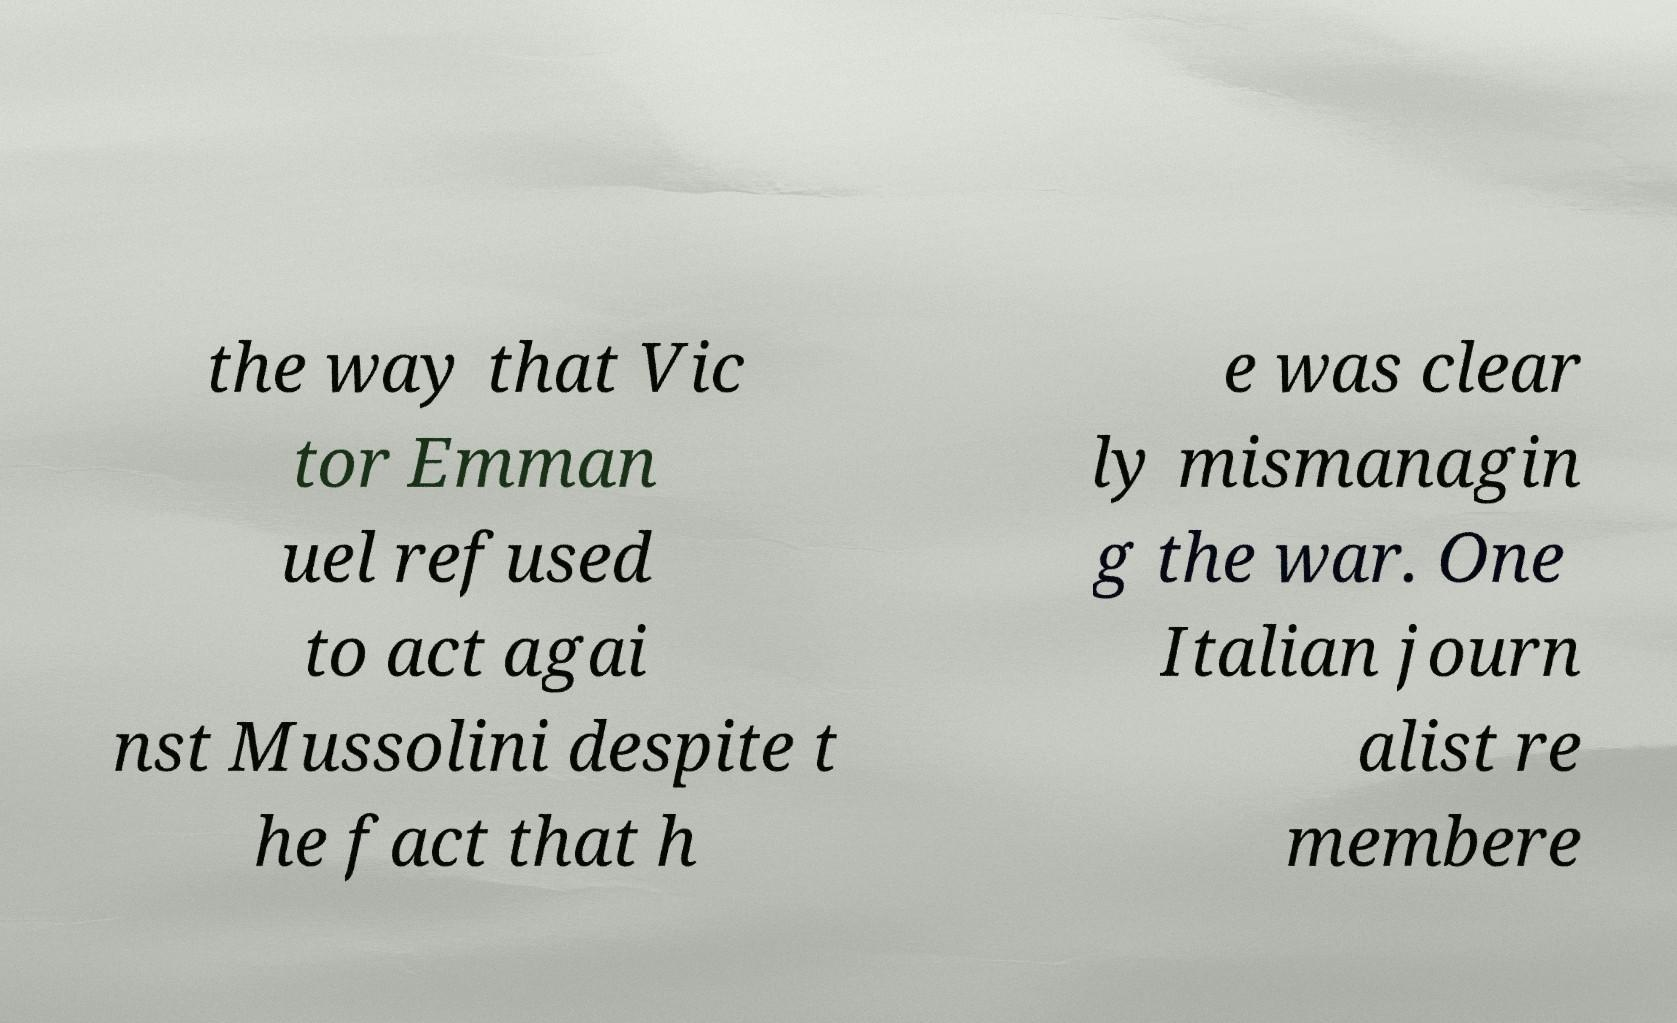Please read and relay the text visible in this image. What does it say? the way that Vic tor Emman uel refused to act agai nst Mussolini despite t he fact that h e was clear ly mismanagin g the war. One Italian journ alist re membere 